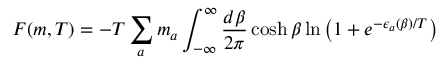Convert formula to latex. <formula><loc_0><loc_0><loc_500><loc_500>F ( m , T ) = - T \sum _ { a } m _ { a } \int _ { - \infty } ^ { \infty } \frac { d \beta } { 2 \pi } \cosh \beta \ln \left ( 1 + e ^ { - \epsilon _ { a } ( \beta ) / T } \right )</formula> 